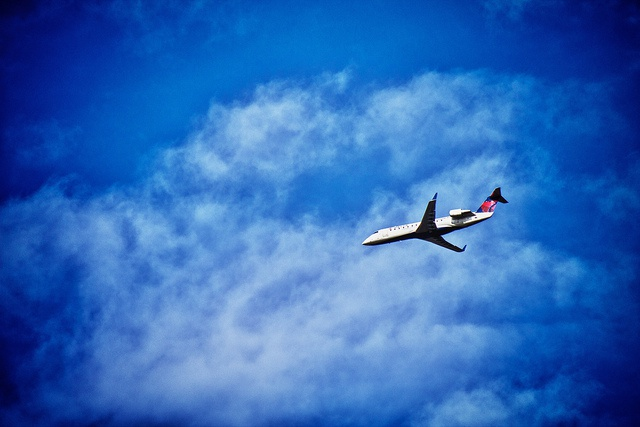Describe the objects in this image and their specific colors. I can see a airplane in black, white, navy, and gray tones in this image. 